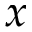Convert formula to latex. <formula><loc_0><loc_0><loc_500><loc_500>x</formula> 